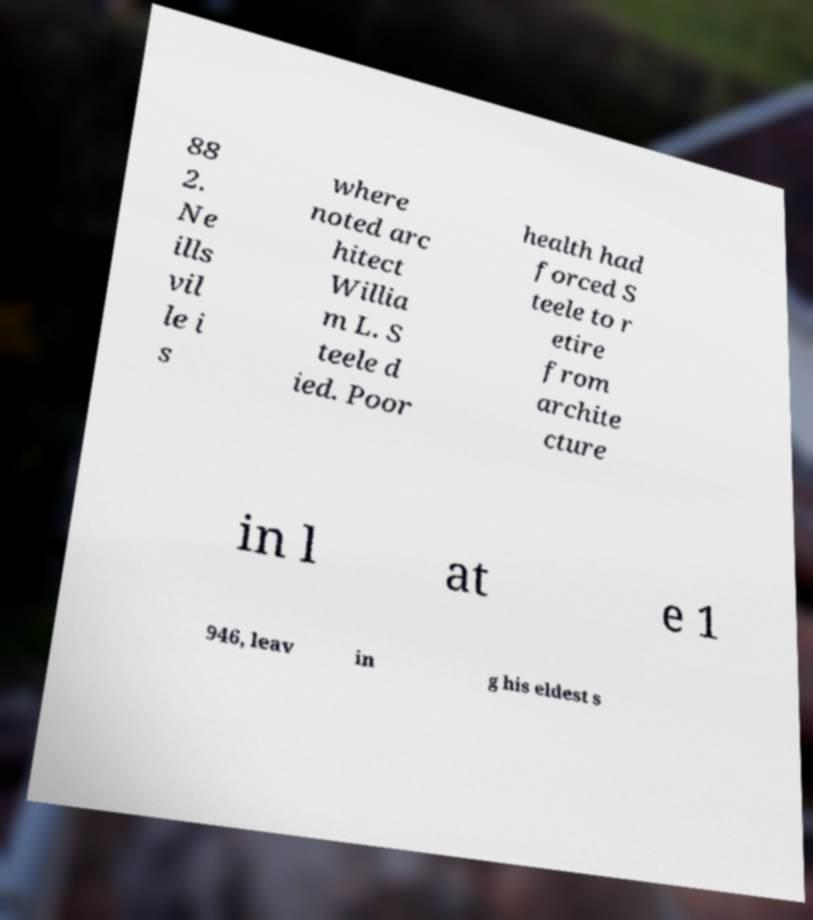Please identify and transcribe the text found in this image. 88 2. Ne ills vil le i s where noted arc hitect Willia m L. S teele d ied. Poor health had forced S teele to r etire from archite cture in l at e 1 946, leav in g his eldest s 